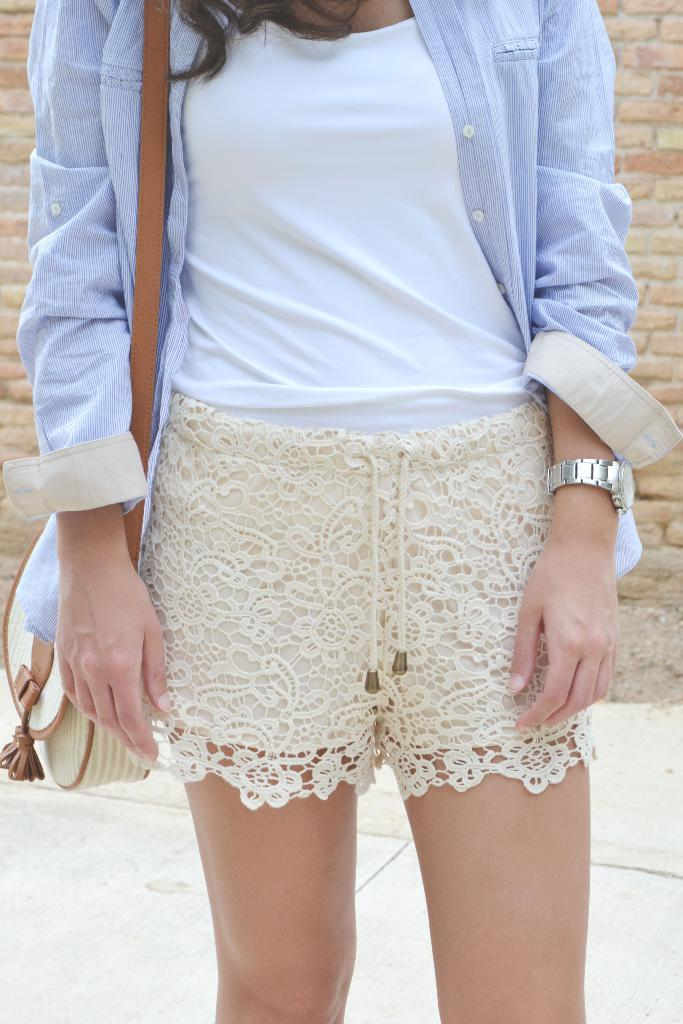What is the main subject of the image? The main subject of the image is a woman. Where is the woman positioned in the image? The woman is standing in the center of the image. What is the woman standing on? The woman is standing on the floor. What can be seen in the background of the image? There is a wall in the background of the image. What type of shock can be seen affecting the girl in the image? There is no girl present in the image, and therefore no shock can be observed. 